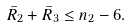<formula> <loc_0><loc_0><loc_500><loc_500>\bar { R } _ { 2 } + \bar { R } _ { 3 } \leq n _ { 2 } - 6 .</formula> 